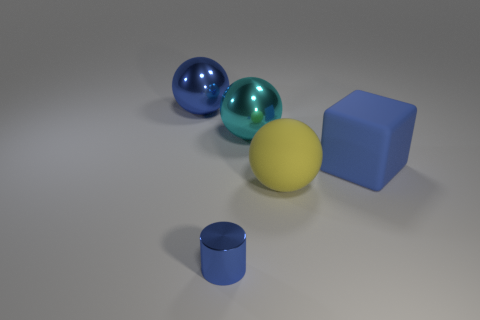Subtract all metallic balls. How many balls are left? 1 Subtract all blue balls. How many balls are left? 2 Subtract all red cylinders. How many blue balls are left? 1 Subtract 1 spheres. How many spheres are left? 2 Subtract all green cylinders. Subtract all brown spheres. How many cylinders are left? 1 Subtract all gray cylinders. Subtract all yellow rubber balls. How many objects are left? 4 Add 1 small shiny cylinders. How many small shiny cylinders are left? 2 Add 1 brown metal cylinders. How many brown metal cylinders exist? 1 Add 2 small blue objects. How many objects exist? 7 Subtract 0 yellow cubes. How many objects are left? 5 